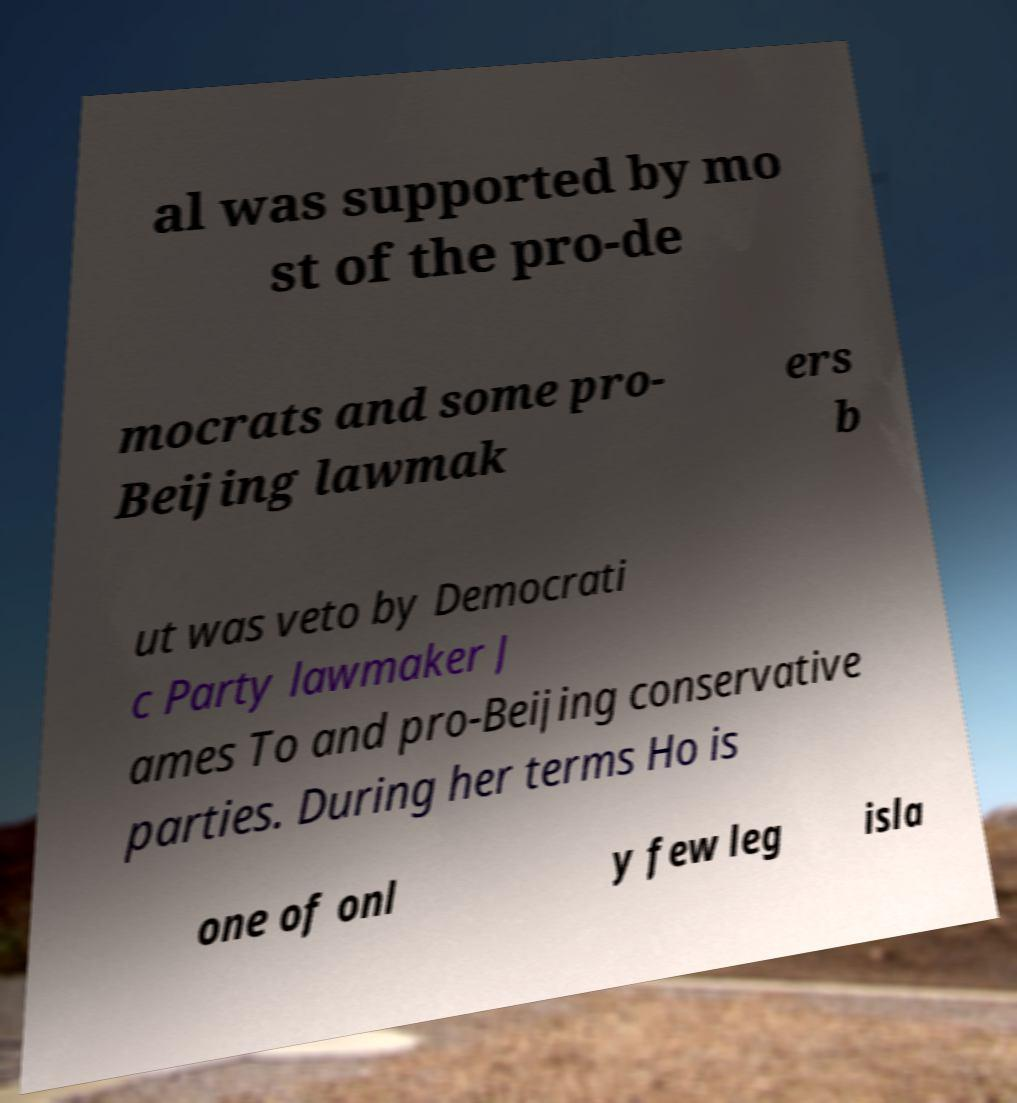I need the written content from this picture converted into text. Can you do that? al was supported by mo st of the pro-de mocrats and some pro- Beijing lawmak ers b ut was veto by Democrati c Party lawmaker J ames To and pro-Beijing conservative parties. During her terms Ho is one of onl y few leg isla 